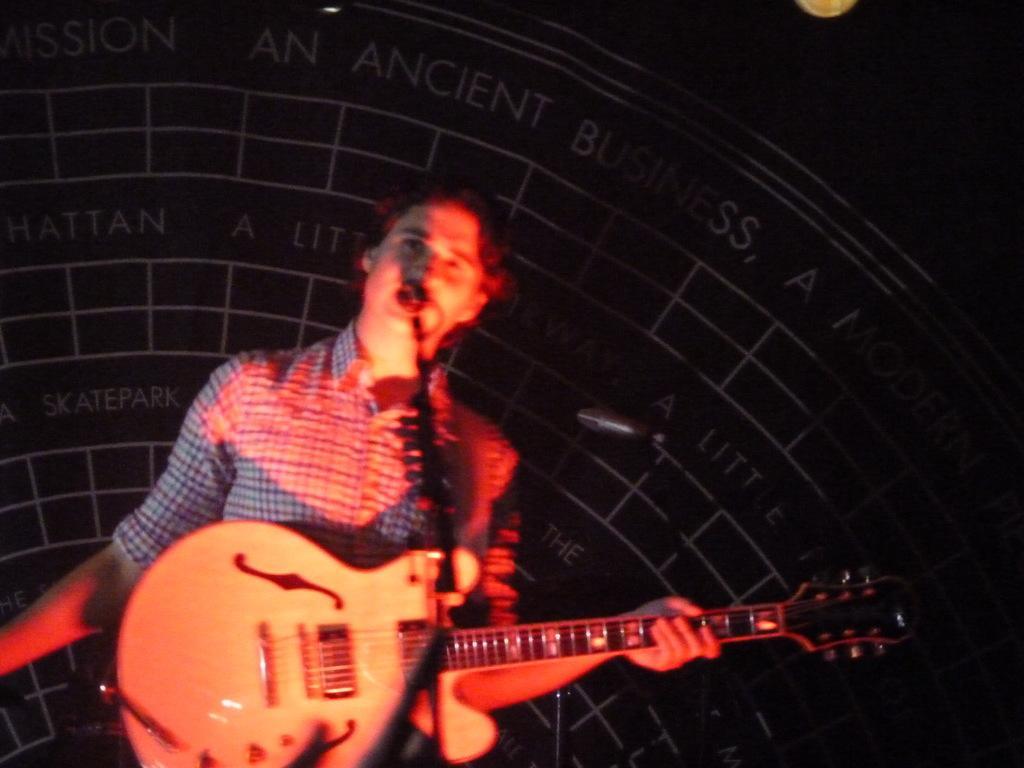In one or two sentences, can you explain what this image depicts? In this image I can see a person holding the guitar. 